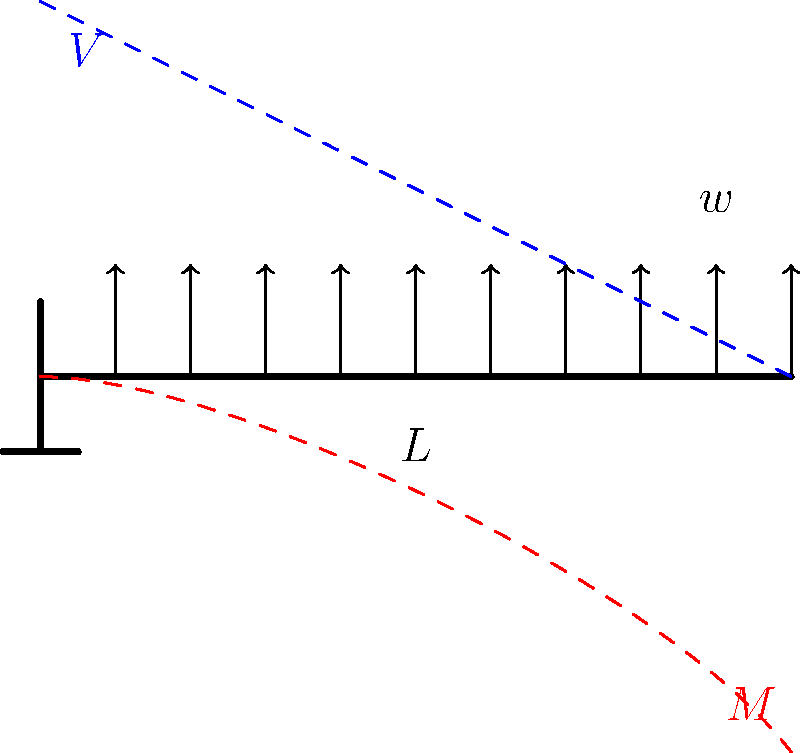In the simplified model of a cantilever bridge shown above, where $w$ represents a uniformly distributed load and $L$ is the length of the beam, sketch the general shapes of the bending moment (M) and shear force (V) diagrams. Which end of the beam experiences the maximum bending moment, and why is this significant for the bridge's design? To analyze the stress distribution in the cantilever bridge:

1. Understand the load distribution:
   - The beam is subjected to a uniformly distributed load $w$ along its entire length $L$.

2. Analyze the support conditions:
   - The left end is fixed (cantilevered), providing both translational and rotational restraint.
   - The right end is free.

3. Bending Moment (M) diagram:
   - The bending moment is zero at the free end (right side).
   - It increases quadratically towards the fixed end (left side).
   - The maximum bending moment occurs at the fixed end.
   - The equation for the bending moment at any point $x$ from the free end is:
     $$ M(x) = \frac{w(L-x)^2}{2} $$

4. Shear Force (V) diagram:
   - The shear force is zero at the free end (right side).
   - It increases linearly towards the fixed end (left side).
   - The maximum shear force occurs at the fixed end.
   - The equation for the shear force at any point $x$ from the free end is:
     $$ V(x) = w(L-x) $$

5. Significance for bridge design:
   - The maximum bending moment at the fixed end is critical for design.
   - This area experiences the highest stresses and is most prone to failure.
   - The bridge design must ensure sufficient strength and stiffness at the support to resist this moment.
   - Materials with high tensile strength are often used in the top fibers near the support.
   - The cross-section of the beam may be varied along its length to optimize material usage.
Answer: Maximum bending moment occurs at the fixed end; critical for strength and material selection at the support. 